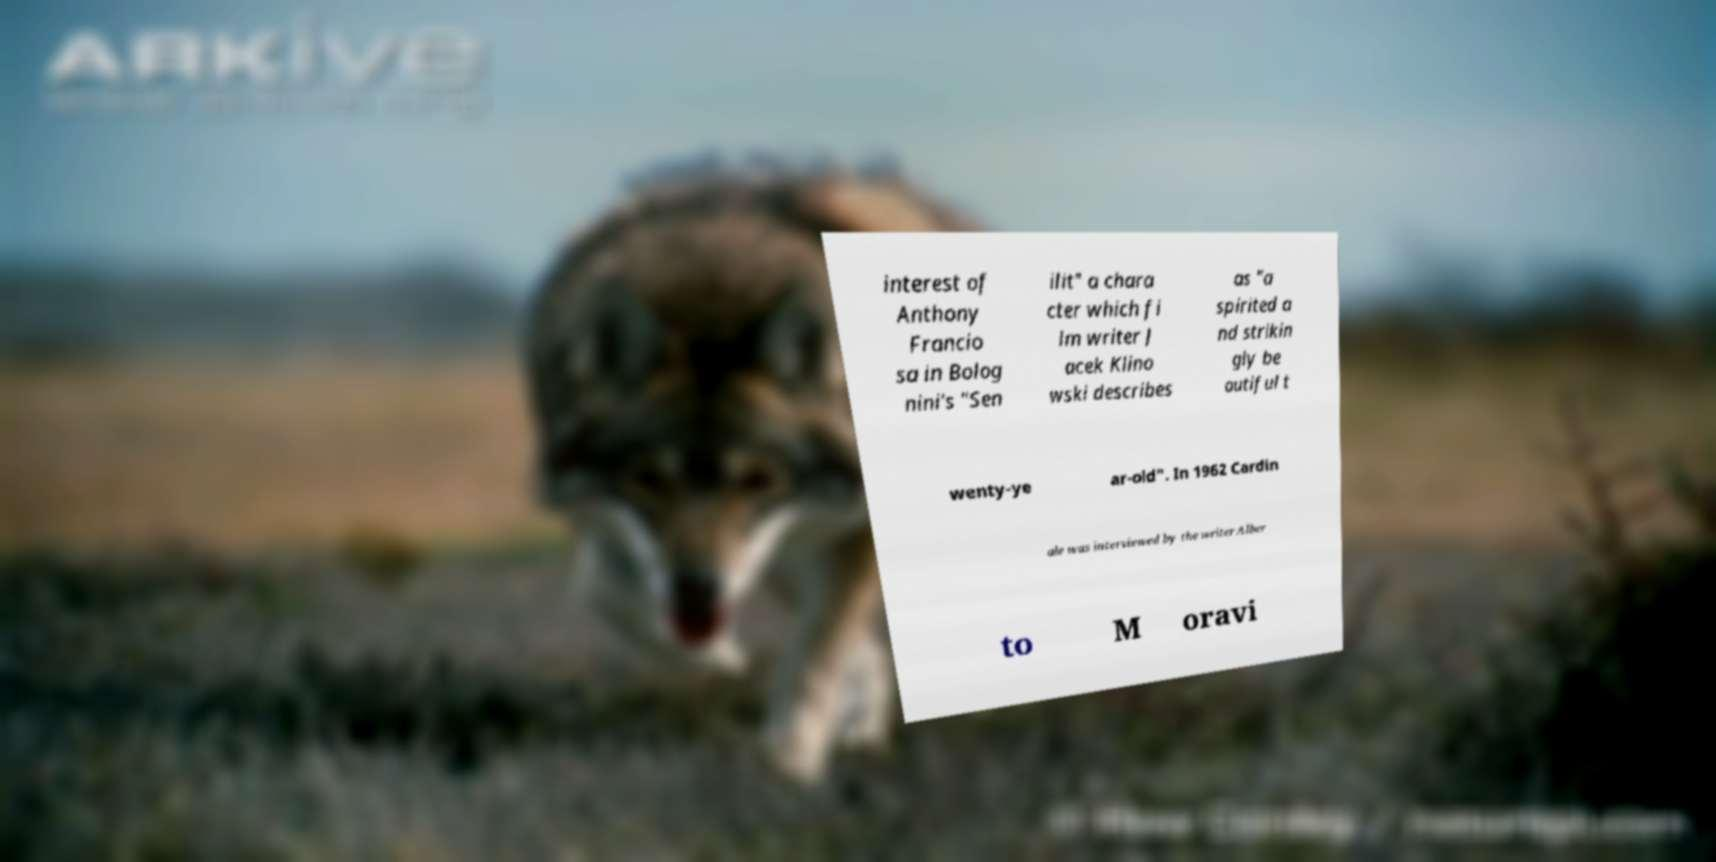Please identify and transcribe the text found in this image. interest of Anthony Francio sa in Bolog nini's "Sen ilit" a chara cter which fi lm writer J acek Klino wski describes as "a spirited a nd strikin gly be autiful t wenty-ye ar-old". In 1962 Cardin ale was interviewed by the writer Alber to M oravi 